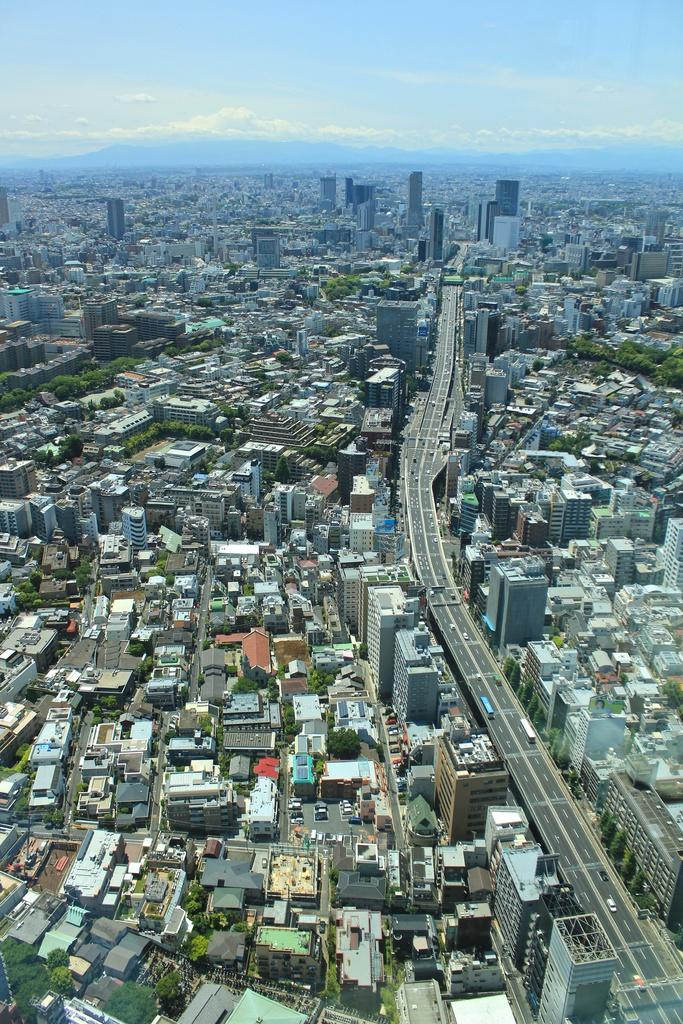What can be seen on the road in the image? There are vehicles on the road in the image. What type of structures are visible in the image? There are buildings visible in the image. What type of vegetation is present in the image? There are trees in the image. What is visible in the background of the image? The sky is visible in the background of the image. Who is the beginner in the image? There is no reference to a beginner in the image. What act is being performed by the creator in the image? There is no creator or act being performed in the image. 